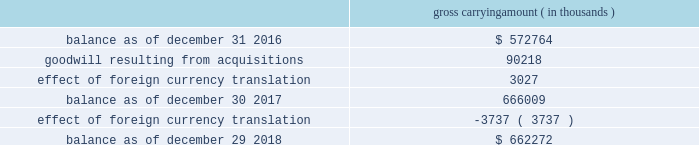Note 8 .
Acquisitions during fiscal 2017 , cadence completed two business combinations for total cash consideration of $ 142.8 million , after taking into account cash acquired of $ 4.2 million .
The total purchase consideration was allocated to the assets acquired and liabilities assumed based on their respective estimated fair values on the acquisition dates .
Cadence recorded a total of $ 76.4 million of acquired intangible assets ( of which $ 71.5 million represents in-process technology ) , $ 90.2 million of goodwill and $ 19.6 million of net liabilities consisting primarily of deferred tax liabilities .
Cadence will also make payments to certain employees , subject to continued employment and other performance-based conditions , through the fourth quarter of fiscal 2020 .
During fiscal 2016 , cadence completed two business combinations for total cash consideration of $ 42.4 million , after taking into account cash acquired of $ 1.8 million .
The total purchase consideration was allocated to the assets acquired and liabilities assumed based on their respective estimated fair values on the acquisition dates .
Cadence recorded a total of $ 23.6 million of goodwill , $ 23.2 million of acquired intangible assets and $ 2.6 million of net liabilities consisting primarily of deferred revenue .
Cadence will also make payments to certain employees , subject to continued employment and other conditions , through the second quarter of fiscal a trust for the benefit of the children of lip-bu tan , cadence 2019s chief executive officer ( 201cceo 201d ) and director , owned less than 3% ( 3 % ) of nusemi inc , one of the companies acquired in 2017 , and less than 2% ( 2 % ) of rocketick technologies ltd. , one of the companies acquired in 2016 .
Mr .
Tan and his wife serve as co-trustees of the trust and disclaim pecuniary and economic interest in the trust .
The board of directors of cadence reviewed the transactions and concluded that it was in the best interests of cadence to proceed with the transactions .
Mr .
Tan recused himself from the board of directors 2019 discussion of the valuation of nusemi inc and rocketick technologies ltd .
And on whether to proceed with the transactions .
Acquisition-related transaction costs there were no direct transaction costs associated with acquisitions during fiscal 2018 .
Transaction costs associated with acquisitions were $ 0.6 million and $ 1.1 million during fiscal 2017 and 2016 , respectively .
These costs consist of professional fees and administrative costs and were expensed as incurred in cadence 2019s consolidated income statements .
Note 9 .
Goodwill and acquired intangibles goodwill the changes in the carrying amount of goodwill during fiscal 2018 and 2017 were as follows : gross carrying amount ( in thousands ) .
Cadence completed its annual goodwill impairment test during the third quarter of fiscal 2018 and determined that the fair value of cadence 2019s single reporting unit substantially exceeded the carrying amount of its net assets and that no impairment existed. .
What is the percentage increase in the balance of goodwill from 2016 to 2017? 
Computations: ((666009 - 572764) / 572764)
Answer: 0.1628. 